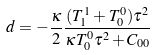<formula> <loc_0><loc_0><loc_500><loc_500>d = - \frac { \kappa } { 2 } \frac { ( T _ { 1 } ^ { 1 } + T _ { 0 } ^ { 0 } ) \tau ^ { 2 } } { \kappa T _ { 0 } ^ { 0 } \tau ^ { 2 } + C _ { 0 0 } }</formula> 